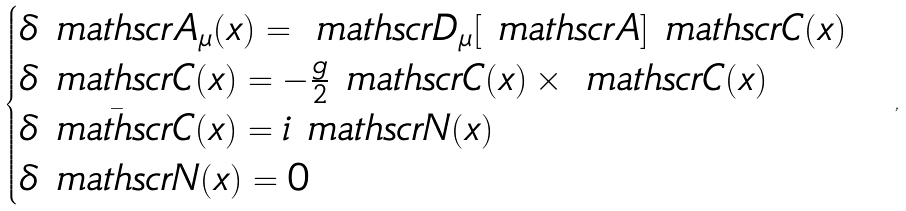Convert formula to latex. <formula><loc_0><loc_0><loc_500><loc_500>\begin{cases} { \boldsymbol \delta } \ m a t h s c r { A } _ { \mu } ( x ) = \ m a t h s c r { D } _ { \mu } [ \ m a t h s c r { A } ] \ m a t h s c r { C } ( x ) \\ { \boldsymbol \delta } \ m a t h s c r { C } ( x ) = - \frac { g } { 2 } \ m a t h s c r { C } ( x ) \times \ m a t h s c r { C } ( x ) \\ { \boldsymbol \delta } \bar { \ m a t h s c r { C } } ( x ) = i \ m a t h s c r { N } ( x ) \\ { \boldsymbol \delta } \ m a t h s c r { N } ( x ) = 0 \\ \end{cases} ,</formula> 